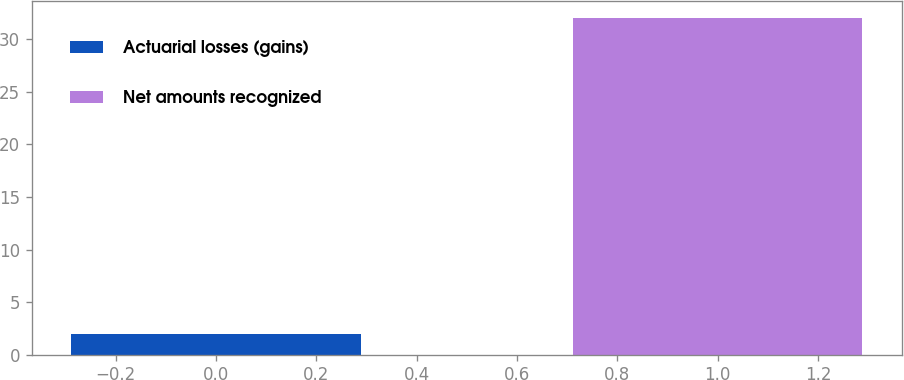<chart> <loc_0><loc_0><loc_500><loc_500><bar_chart><fcel>Actuarial losses (gains)<fcel>Net amounts recognized<nl><fcel>2<fcel>32<nl></chart> 